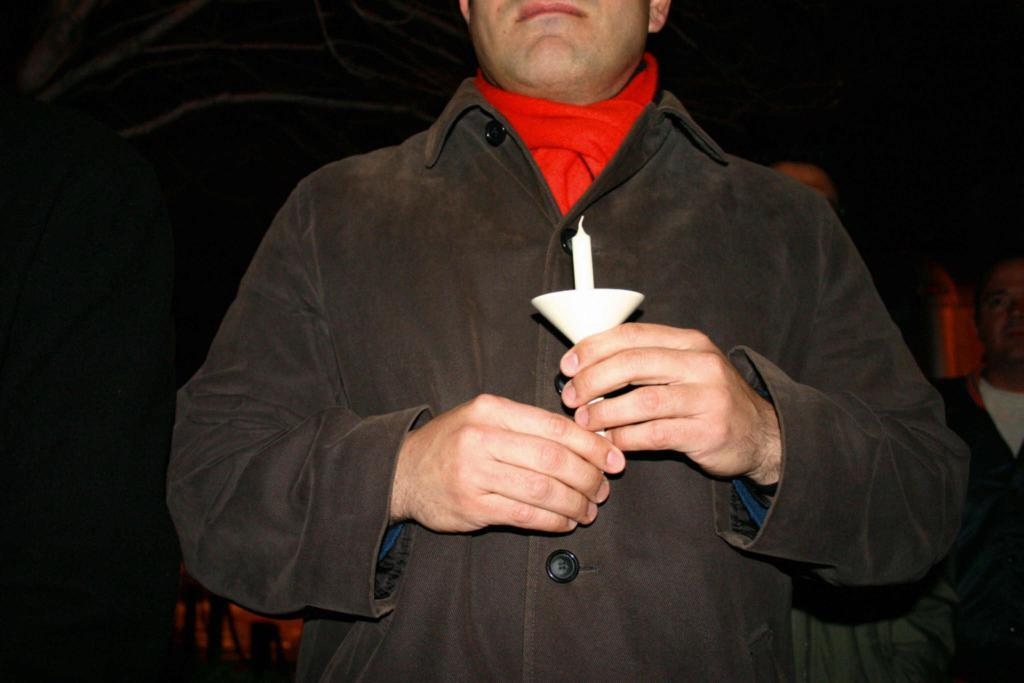What is the main subject of the image? There is a man standing in the image. What is the man holding in the image? The man is holding a white object. What type of clothing is the man wearing? The man is wearing a jacket. What type of pancake is the man flipping in the image? There is no pancake present in the image, and the man is not flipping anything. 